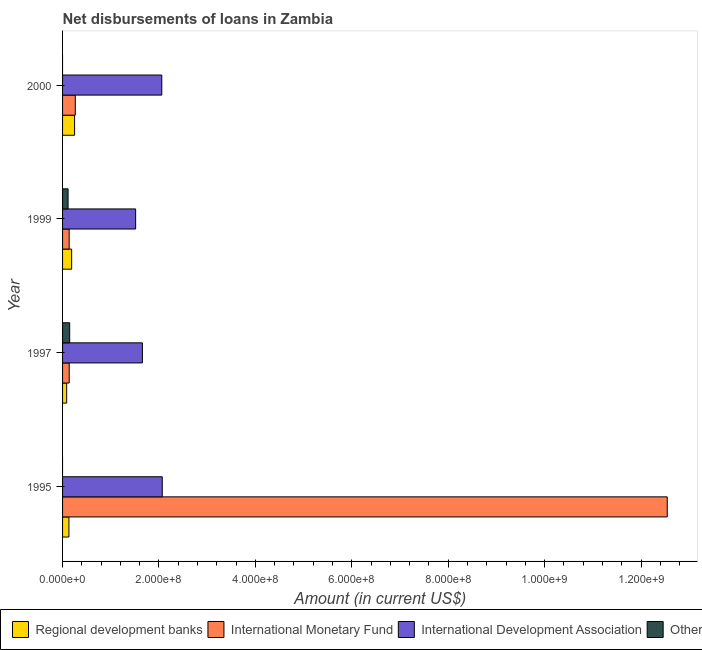How many different coloured bars are there?
Keep it short and to the point. 4. How many groups of bars are there?
Offer a very short reply. 4. How many bars are there on the 1st tick from the bottom?
Ensure brevity in your answer.  3. In how many cases, is the number of bars for a given year not equal to the number of legend labels?
Your answer should be compact. 2. What is the amount of loan disimbursed by other organisations in 1999?
Your answer should be very brief. 1.14e+07. Across all years, what is the maximum amount of loan disimbursed by international development association?
Provide a succinct answer. 2.07e+08. Across all years, what is the minimum amount of loan disimbursed by regional development banks?
Offer a terse response. 8.50e+06. In which year was the amount of loan disimbursed by regional development banks maximum?
Your answer should be compact. 2000. What is the total amount of loan disimbursed by international development association in the graph?
Offer a very short reply. 7.30e+08. What is the difference between the amount of loan disimbursed by other organisations in 1997 and that in 1999?
Offer a terse response. 3.32e+06. What is the difference between the amount of loan disimbursed by regional development banks in 2000 and the amount of loan disimbursed by international development association in 1997?
Offer a terse response. -1.41e+08. What is the average amount of loan disimbursed by international development association per year?
Keep it short and to the point. 1.82e+08. In the year 2000, what is the difference between the amount of loan disimbursed by regional development banks and amount of loan disimbursed by international monetary fund?
Your answer should be compact. -1.40e+06. What is the ratio of the amount of loan disimbursed by other organisations in 1997 to that in 1999?
Make the answer very short. 1.29. Is the amount of loan disimbursed by regional development banks in 1997 less than that in 2000?
Provide a short and direct response. Yes. What is the difference between the highest and the second highest amount of loan disimbursed by international monetary fund?
Offer a terse response. 1.23e+09. What is the difference between the highest and the lowest amount of loan disimbursed by international monetary fund?
Offer a terse response. 1.24e+09. In how many years, is the amount of loan disimbursed by international monetary fund greater than the average amount of loan disimbursed by international monetary fund taken over all years?
Provide a succinct answer. 1. Is it the case that in every year, the sum of the amount of loan disimbursed by regional development banks and amount of loan disimbursed by international monetary fund is greater than the amount of loan disimbursed by international development association?
Your response must be concise. No. Are all the bars in the graph horizontal?
Ensure brevity in your answer.  Yes. How many years are there in the graph?
Offer a very short reply. 4. What is the difference between two consecutive major ticks on the X-axis?
Provide a succinct answer. 2.00e+08. How many legend labels are there?
Keep it short and to the point. 4. How are the legend labels stacked?
Give a very brief answer. Horizontal. What is the title of the graph?
Your answer should be very brief. Net disbursements of loans in Zambia. Does "Oil" appear as one of the legend labels in the graph?
Offer a very short reply. No. What is the label or title of the X-axis?
Provide a short and direct response. Amount (in current US$). What is the Amount (in current US$) in Regional development banks in 1995?
Make the answer very short. 1.32e+07. What is the Amount (in current US$) in International Monetary Fund in 1995?
Your answer should be very brief. 1.25e+09. What is the Amount (in current US$) of International Development Association in 1995?
Provide a succinct answer. 2.07e+08. What is the Amount (in current US$) in Others in 1995?
Ensure brevity in your answer.  0. What is the Amount (in current US$) in Regional development banks in 1997?
Your answer should be compact. 8.50e+06. What is the Amount (in current US$) of International Monetary Fund in 1997?
Ensure brevity in your answer.  1.38e+07. What is the Amount (in current US$) of International Development Association in 1997?
Ensure brevity in your answer.  1.66e+08. What is the Amount (in current US$) of Others in 1997?
Provide a short and direct response. 1.48e+07. What is the Amount (in current US$) in Regional development banks in 1999?
Provide a succinct answer. 1.88e+07. What is the Amount (in current US$) of International Monetary Fund in 1999?
Give a very brief answer. 1.37e+07. What is the Amount (in current US$) of International Development Association in 1999?
Provide a succinct answer. 1.52e+08. What is the Amount (in current US$) in Others in 1999?
Your answer should be very brief. 1.14e+07. What is the Amount (in current US$) of Regional development banks in 2000?
Make the answer very short. 2.50e+07. What is the Amount (in current US$) in International Monetary Fund in 2000?
Offer a terse response. 2.64e+07. What is the Amount (in current US$) of International Development Association in 2000?
Ensure brevity in your answer.  2.06e+08. What is the Amount (in current US$) of Others in 2000?
Give a very brief answer. 0. Across all years, what is the maximum Amount (in current US$) in Regional development banks?
Make the answer very short. 2.50e+07. Across all years, what is the maximum Amount (in current US$) in International Monetary Fund?
Keep it short and to the point. 1.25e+09. Across all years, what is the maximum Amount (in current US$) of International Development Association?
Your answer should be very brief. 2.07e+08. Across all years, what is the maximum Amount (in current US$) in Others?
Give a very brief answer. 1.48e+07. Across all years, what is the minimum Amount (in current US$) of Regional development banks?
Offer a very short reply. 8.50e+06. Across all years, what is the minimum Amount (in current US$) in International Monetary Fund?
Ensure brevity in your answer.  1.37e+07. Across all years, what is the minimum Amount (in current US$) in International Development Association?
Your response must be concise. 1.52e+08. Across all years, what is the minimum Amount (in current US$) in Others?
Ensure brevity in your answer.  0. What is the total Amount (in current US$) of Regional development banks in the graph?
Offer a very short reply. 6.55e+07. What is the total Amount (in current US$) in International Monetary Fund in the graph?
Your answer should be very brief. 1.31e+09. What is the total Amount (in current US$) of International Development Association in the graph?
Your answer should be very brief. 7.30e+08. What is the total Amount (in current US$) in Others in the graph?
Your response must be concise. 2.62e+07. What is the difference between the Amount (in current US$) of Regional development banks in 1995 and that in 1997?
Offer a terse response. 4.68e+06. What is the difference between the Amount (in current US$) in International Monetary Fund in 1995 and that in 1997?
Your answer should be very brief. 1.24e+09. What is the difference between the Amount (in current US$) in International Development Association in 1995 and that in 1997?
Offer a very short reply. 4.12e+07. What is the difference between the Amount (in current US$) in Regional development banks in 1995 and that in 1999?
Your answer should be very brief. -5.66e+06. What is the difference between the Amount (in current US$) in International Monetary Fund in 1995 and that in 1999?
Offer a very short reply. 1.24e+09. What is the difference between the Amount (in current US$) of International Development Association in 1995 and that in 1999?
Provide a succinct answer. 5.52e+07. What is the difference between the Amount (in current US$) in Regional development banks in 1995 and that in 2000?
Provide a short and direct response. -1.18e+07. What is the difference between the Amount (in current US$) in International Monetary Fund in 1995 and that in 2000?
Offer a very short reply. 1.23e+09. What is the difference between the Amount (in current US$) in International Development Association in 1995 and that in 2000?
Ensure brevity in your answer.  9.71e+05. What is the difference between the Amount (in current US$) of Regional development banks in 1997 and that in 1999?
Your response must be concise. -1.03e+07. What is the difference between the Amount (in current US$) of International Monetary Fund in 1997 and that in 1999?
Your response must be concise. 8.70e+04. What is the difference between the Amount (in current US$) in International Development Association in 1997 and that in 1999?
Offer a terse response. 1.40e+07. What is the difference between the Amount (in current US$) in Others in 1997 and that in 1999?
Your answer should be compact. 3.32e+06. What is the difference between the Amount (in current US$) in Regional development banks in 1997 and that in 2000?
Give a very brief answer. -1.65e+07. What is the difference between the Amount (in current US$) of International Monetary Fund in 1997 and that in 2000?
Offer a very short reply. -1.26e+07. What is the difference between the Amount (in current US$) in International Development Association in 1997 and that in 2000?
Your answer should be compact. -4.02e+07. What is the difference between the Amount (in current US$) of Regional development banks in 1999 and that in 2000?
Your answer should be very brief. -6.13e+06. What is the difference between the Amount (in current US$) in International Monetary Fund in 1999 and that in 2000?
Ensure brevity in your answer.  -1.27e+07. What is the difference between the Amount (in current US$) in International Development Association in 1999 and that in 2000?
Ensure brevity in your answer.  -5.42e+07. What is the difference between the Amount (in current US$) of Regional development banks in 1995 and the Amount (in current US$) of International Monetary Fund in 1997?
Your answer should be compact. -5.78e+05. What is the difference between the Amount (in current US$) in Regional development banks in 1995 and the Amount (in current US$) in International Development Association in 1997?
Ensure brevity in your answer.  -1.52e+08. What is the difference between the Amount (in current US$) in Regional development banks in 1995 and the Amount (in current US$) in Others in 1997?
Give a very brief answer. -1.58e+06. What is the difference between the Amount (in current US$) of International Monetary Fund in 1995 and the Amount (in current US$) of International Development Association in 1997?
Offer a terse response. 1.09e+09. What is the difference between the Amount (in current US$) in International Monetary Fund in 1995 and the Amount (in current US$) in Others in 1997?
Provide a short and direct response. 1.24e+09. What is the difference between the Amount (in current US$) in International Development Association in 1995 and the Amount (in current US$) in Others in 1997?
Provide a succinct answer. 1.92e+08. What is the difference between the Amount (in current US$) of Regional development banks in 1995 and the Amount (in current US$) of International Monetary Fund in 1999?
Offer a terse response. -4.91e+05. What is the difference between the Amount (in current US$) of Regional development banks in 1995 and the Amount (in current US$) of International Development Association in 1999?
Your response must be concise. -1.38e+08. What is the difference between the Amount (in current US$) of Regional development banks in 1995 and the Amount (in current US$) of Others in 1999?
Your answer should be compact. 1.74e+06. What is the difference between the Amount (in current US$) in International Monetary Fund in 1995 and the Amount (in current US$) in International Development Association in 1999?
Your answer should be very brief. 1.10e+09. What is the difference between the Amount (in current US$) of International Monetary Fund in 1995 and the Amount (in current US$) of Others in 1999?
Your answer should be very brief. 1.24e+09. What is the difference between the Amount (in current US$) of International Development Association in 1995 and the Amount (in current US$) of Others in 1999?
Your answer should be compact. 1.95e+08. What is the difference between the Amount (in current US$) of Regional development banks in 1995 and the Amount (in current US$) of International Monetary Fund in 2000?
Ensure brevity in your answer.  -1.32e+07. What is the difference between the Amount (in current US$) of Regional development banks in 1995 and the Amount (in current US$) of International Development Association in 2000?
Offer a terse response. -1.93e+08. What is the difference between the Amount (in current US$) of International Monetary Fund in 1995 and the Amount (in current US$) of International Development Association in 2000?
Provide a succinct answer. 1.05e+09. What is the difference between the Amount (in current US$) of Regional development banks in 1997 and the Amount (in current US$) of International Monetary Fund in 1999?
Your answer should be very brief. -5.17e+06. What is the difference between the Amount (in current US$) of Regional development banks in 1997 and the Amount (in current US$) of International Development Association in 1999?
Offer a terse response. -1.43e+08. What is the difference between the Amount (in current US$) in Regional development banks in 1997 and the Amount (in current US$) in Others in 1999?
Ensure brevity in your answer.  -2.93e+06. What is the difference between the Amount (in current US$) of International Monetary Fund in 1997 and the Amount (in current US$) of International Development Association in 1999?
Give a very brief answer. -1.38e+08. What is the difference between the Amount (in current US$) of International Monetary Fund in 1997 and the Amount (in current US$) of Others in 1999?
Keep it short and to the point. 2.32e+06. What is the difference between the Amount (in current US$) of International Development Association in 1997 and the Amount (in current US$) of Others in 1999?
Provide a short and direct response. 1.54e+08. What is the difference between the Amount (in current US$) in Regional development banks in 1997 and the Amount (in current US$) in International Monetary Fund in 2000?
Your answer should be compact. -1.79e+07. What is the difference between the Amount (in current US$) of Regional development banks in 1997 and the Amount (in current US$) of International Development Association in 2000?
Give a very brief answer. -1.97e+08. What is the difference between the Amount (in current US$) of International Monetary Fund in 1997 and the Amount (in current US$) of International Development Association in 2000?
Your answer should be very brief. -1.92e+08. What is the difference between the Amount (in current US$) of Regional development banks in 1999 and the Amount (in current US$) of International Monetary Fund in 2000?
Provide a succinct answer. -7.53e+06. What is the difference between the Amount (in current US$) in Regional development banks in 1999 and the Amount (in current US$) in International Development Association in 2000?
Keep it short and to the point. -1.87e+08. What is the difference between the Amount (in current US$) of International Monetary Fund in 1999 and the Amount (in current US$) of International Development Association in 2000?
Keep it short and to the point. -1.92e+08. What is the average Amount (in current US$) in Regional development banks per year?
Keep it short and to the point. 1.64e+07. What is the average Amount (in current US$) of International Monetary Fund per year?
Offer a very short reply. 3.27e+08. What is the average Amount (in current US$) in International Development Association per year?
Your answer should be very brief. 1.82e+08. What is the average Amount (in current US$) in Others per year?
Provide a short and direct response. 6.55e+06. In the year 1995, what is the difference between the Amount (in current US$) of Regional development banks and Amount (in current US$) of International Monetary Fund?
Offer a very short reply. -1.24e+09. In the year 1995, what is the difference between the Amount (in current US$) of Regional development banks and Amount (in current US$) of International Development Association?
Give a very brief answer. -1.94e+08. In the year 1995, what is the difference between the Amount (in current US$) of International Monetary Fund and Amount (in current US$) of International Development Association?
Keep it short and to the point. 1.05e+09. In the year 1997, what is the difference between the Amount (in current US$) of Regional development banks and Amount (in current US$) of International Monetary Fund?
Provide a short and direct response. -5.26e+06. In the year 1997, what is the difference between the Amount (in current US$) of Regional development banks and Amount (in current US$) of International Development Association?
Your answer should be compact. -1.57e+08. In the year 1997, what is the difference between the Amount (in current US$) of Regional development banks and Amount (in current US$) of Others?
Provide a succinct answer. -6.25e+06. In the year 1997, what is the difference between the Amount (in current US$) of International Monetary Fund and Amount (in current US$) of International Development Association?
Your answer should be very brief. -1.52e+08. In the year 1997, what is the difference between the Amount (in current US$) in International Monetary Fund and Amount (in current US$) in Others?
Provide a succinct answer. -9.97e+05. In the year 1997, what is the difference between the Amount (in current US$) of International Development Association and Amount (in current US$) of Others?
Make the answer very short. 1.51e+08. In the year 1999, what is the difference between the Amount (in current US$) in Regional development banks and Amount (in current US$) in International Monetary Fund?
Your answer should be compact. 5.17e+06. In the year 1999, what is the difference between the Amount (in current US$) of Regional development banks and Amount (in current US$) of International Development Association?
Make the answer very short. -1.33e+08. In the year 1999, what is the difference between the Amount (in current US$) in Regional development banks and Amount (in current US$) in Others?
Offer a terse response. 7.41e+06. In the year 1999, what is the difference between the Amount (in current US$) of International Monetary Fund and Amount (in current US$) of International Development Association?
Provide a short and direct response. -1.38e+08. In the year 1999, what is the difference between the Amount (in current US$) of International Monetary Fund and Amount (in current US$) of Others?
Offer a terse response. 2.24e+06. In the year 1999, what is the difference between the Amount (in current US$) in International Development Association and Amount (in current US$) in Others?
Your response must be concise. 1.40e+08. In the year 2000, what is the difference between the Amount (in current US$) in Regional development banks and Amount (in current US$) in International Monetary Fund?
Ensure brevity in your answer.  -1.40e+06. In the year 2000, what is the difference between the Amount (in current US$) in Regional development banks and Amount (in current US$) in International Development Association?
Offer a terse response. -1.81e+08. In the year 2000, what is the difference between the Amount (in current US$) in International Monetary Fund and Amount (in current US$) in International Development Association?
Provide a succinct answer. -1.79e+08. What is the ratio of the Amount (in current US$) of Regional development banks in 1995 to that in 1997?
Keep it short and to the point. 1.55. What is the ratio of the Amount (in current US$) of International Monetary Fund in 1995 to that in 1997?
Provide a succinct answer. 91.16. What is the ratio of the Amount (in current US$) of International Development Association in 1995 to that in 1997?
Your answer should be compact. 1.25. What is the ratio of the Amount (in current US$) of Regional development banks in 1995 to that in 1999?
Keep it short and to the point. 0.7. What is the ratio of the Amount (in current US$) of International Monetary Fund in 1995 to that in 1999?
Keep it short and to the point. 91.74. What is the ratio of the Amount (in current US$) of International Development Association in 1995 to that in 1999?
Offer a terse response. 1.36. What is the ratio of the Amount (in current US$) of Regional development banks in 1995 to that in 2000?
Provide a succinct answer. 0.53. What is the ratio of the Amount (in current US$) in International Monetary Fund in 1995 to that in 2000?
Provide a succinct answer. 47.55. What is the ratio of the Amount (in current US$) in Regional development banks in 1997 to that in 1999?
Offer a terse response. 0.45. What is the ratio of the Amount (in current US$) of International Monetary Fund in 1997 to that in 1999?
Your answer should be very brief. 1.01. What is the ratio of the Amount (in current US$) of International Development Association in 1997 to that in 1999?
Make the answer very short. 1.09. What is the ratio of the Amount (in current US$) in Others in 1997 to that in 1999?
Give a very brief answer. 1.29. What is the ratio of the Amount (in current US$) in Regional development banks in 1997 to that in 2000?
Provide a short and direct response. 0.34. What is the ratio of the Amount (in current US$) of International Monetary Fund in 1997 to that in 2000?
Your response must be concise. 0.52. What is the ratio of the Amount (in current US$) of International Development Association in 1997 to that in 2000?
Provide a short and direct response. 0.8. What is the ratio of the Amount (in current US$) of Regional development banks in 1999 to that in 2000?
Your response must be concise. 0.75. What is the ratio of the Amount (in current US$) in International Monetary Fund in 1999 to that in 2000?
Make the answer very short. 0.52. What is the ratio of the Amount (in current US$) in International Development Association in 1999 to that in 2000?
Your answer should be very brief. 0.74. What is the difference between the highest and the second highest Amount (in current US$) in Regional development banks?
Your response must be concise. 6.13e+06. What is the difference between the highest and the second highest Amount (in current US$) of International Monetary Fund?
Provide a short and direct response. 1.23e+09. What is the difference between the highest and the second highest Amount (in current US$) of International Development Association?
Offer a terse response. 9.71e+05. What is the difference between the highest and the lowest Amount (in current US$) in Regional development banks?
Make the answer very short. 1.65e+07. What is the difference between the highest and the lowest Amount (in current US$) of International Monetary Fund?
Offer a terse response. 1.24e+09. What is the difference between the highest and the lowest Amount (in current US$) in International Development Association?
Your answer should be compact. 5.52e+07. What is the difference between the highest and the lowest Amount (in current US$) of Others?
Ensure brevity in your answer.  1.48e+07. 